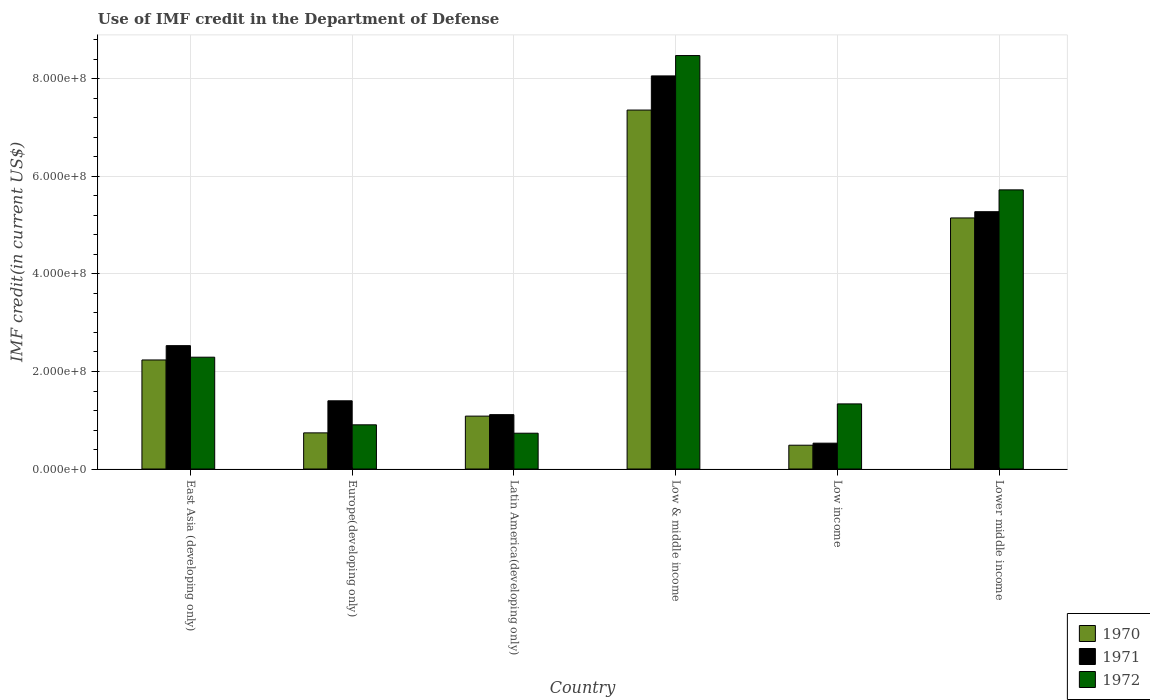How many different coloured bars are there?
Offer a terse response. 3. How many groups of bars are there?
Keep it short and to the point. 6. Are the number of bars per tick equal to the number of legend labels?
Keep it short and to the point. Yes. Are the number of bars on each tick of the X-axis equal?
Keep it short and to the point. Yes. How many bars are there on the 2nd tick from the left?
Provide a succinct answer. 3. What is the label of the 5th group of bars from the left?
Your answer should be compact. Low income. What is the IMF credit in the Department of Defense in 1970 in East Asia (developing only)?
Your response must be concise. 2.24e+08. Across all countries, what is the maximum IMF credit in the Department of Defense in 1972?
Your response must be concise. 8.48e+08. Across all countries, what is the minimum IMF credit in the Department of Defense in 1970?
Your answer should be very brief. 4.88e+07. What is the total IMF credit in the Department of Defense in 1971 in the graph?
Provide a short and direct response. 1.89e+09. What is the difference between the IMF credit in the Department of Defense in 1972 in East Asia (developing only) and that in Europe(developing only)?
Provide a short and direct response. 1.39e+08. What is the difference between the IMF credit in the Department of Defense in 1971 in Latin America(developing only) and the IMF credit in the Department of Defense in 1972 in Lower middle income?
Keep it short and to the point. -4.61e+08. What is the average IMF credit in the Department of Defense in 1970 per country?
Ensure brevity in your answer.  2.84e+08. What is the difference between the IMF credit in the Department of Defense of/in 1971 and IMF credit in the Department of Defense of/in 1972 in East Asia (developing only)?
Give a very brief answer. 2.37e+07. In how many countries, is the IMF credit in the Department of Defense in 1972 greater than 480000000 US$?
Offer a very short reply. 2. What is the ratio of the IMF credit in the Department of Defense in 1970 in Latin America(developing only) to that in Lower middle income?
Give a very brief answer. 0.21. Is the IMF credit in the Department of Defense in 1971 in East Asia (developing only) less than that in Europe(developing only)?
Offer a very short reply. No. Is the difference between the IMF credit in the Department of Defense in 1971 in Low & middle income and Lower middle income greater than the difference between the IMF credit in the Department of Defense in 1972 in Low & middle income and Lower middle income?
Your response must be concise. Yes. What is the difference between the highest and the second highest IMF credit in the Department of Defense in 1970?
Offer a very short reply. 5.13e+08. What is the difference between the highest and the lowest IMF credit in the Department of Defense in 1972?
Keep it short and to the point. 7.75e+08. In how many countries, is the IMF credit in the Department of Defense in 1972 greater than the average IMF credit in the Department of Defense in 1972 taken over all countries?
Provide a succinct answer. 2. What does the 3rd bar from the right in Europe(developing only) represents?
Offer a terse response. 1970. Is it the case that in every country, the sum of the IMF credit in the Department of Defense in 1970 and IMF credit in the Department of Defense in 1972 is greater than the IMF credit in the Department of Defense in 1971?
Offer a very short reply. Yes. How many countries are there in the graph?
Your answer should be very brief. 6. Does the graph contain grids?
Provide a succinct answer. Yes. Where does the legend appear in the graph?
Provide a succinct answer. Bottom right. How many legend labels are there?
Offer a very short reply. 3. How are the legend labels stacked?
Keep it short and to the point. Vertical. What is the title of the graph?
Provide a succinct answer. Use of IMF credit in the Department of Defense. What is the label or title of the X-axis?
Make the answer very short. Country. What is the label or title of the Y-axis?
Your response must be concise. IMF credit(in current US$). What is the IMF credit(in current US$) of 1970 in East Asia (developing only)?
Keep it short and to the point. 2.24e+08. What is the IMF credit(in current US$) in 1971 in East Asia (developing only)?
Provide a succinct answer. 2.53e+08. What is the IMF credit(in current US$) in 1972 in East Asia (developing only)?
Ensure brevity in your answer.  2.29e+08. What is the IMF credit(in current US$) of 1970 in Europe(developing only)?
Make the answer very short. 7.41e+07. What is the IMF credit(in current US$) in 1971 in Europe(developing only)?
Give a very brief answer. 1.40e+08. What is the IMF credit(in current US$) in 1972 in Europe(developing only)?
Your response must be concise. 9.07e+07. What is the IMF credit(in current US$) of 1970 in Latin America(developing only)?
Provide a short and direct response. 1.09e+08. What is the IMF credit(in current US$) of 1971 in Latin America(developing only)?
Your answer should be compact. 1.12e+08. What is the IMF credit(in current US$) of 1972 in Latin America(developing only)?
Offer a very short reply. 7.34e+07. What is the IMF credit(in current US$) of 1970 in Low & middle income?
Offer a terse response. 7.36e+08. What is the IMF credit(in current US$) in 1971 in Low & middle income?
Your response must be concise. 8.06e+08. What is the IMF credit(in current US$) of 1972 in Low & middle income?
Keep it short and to the point. 8.48e+08. What is the IMF credit(in current US$) of 1970 in Low income?
Provide a succinct answer. 4.88e+07. What is the IMF credit(in current US$) in 1971 in Low income?
Keep it short and to the point. 5.30e+07. What is the IMF credit(in current US$) in 1972 in Low income?
Offer a terse response. 1.34e+08. What is the IMF credit(in current US$) in 1970 in Lower middle income?
Your answer should be very brief. 5.15e+08. What is the IMF credit(in current US$) of 1971 in Lower middle income?
Offer a very short reply. 5.28e+08. What is the IMF credit(in current US$) of 1972 in Lower middle income?
Your answer should be compact. 5.73e+08. Across all countries, what is the maximum IMF credit(in current US$) in 1970?
Your answer should be very brief. 7.36e+08. Across all countries, what is the maximum IMF credit(in current US$) in 1971?
Keep it short and to the point. 8.06e+08. Across all countries, what is the maximum IMF credit(in current US$) of 1972?
Offer a terse response. 8.48e+08. Across all countries, what is the minimum IMF credit(in current US$) in 1970?
Provide a short and direct response. 4.88e+07. Across all countries, what is the minimum IMF credit(in current US$) of 1971?
Your answer should be compact. 5.30e+07. Across all countries, what is the minimum IMF credit(in current US$) of 1972?
Offer a terse response. 7.34e+07. What is the total IMF credit(in current US$) in 1970 in the graph?
Offer a very short reply. 1.71e+09. What is the total IMF credit(in current US$) of 1971 in the graph?
Offer a terse response. 1.89e+09. What is the total IMF credit(in current US$) in 1972 in the graph?
Ensure brevity in your answer.  1.95e+09. What is the difference between the IMF credit(in current US$) of 1970 in East Asia (developing only) and that in Europe(developing only)?
Your response must be concise. 1.50e+08. What is the difference between the IMF credit(in current US$) of 1971 in East Asia (developing only) and that in Europe(developing only)?
Your response must be concise. 1.13e+08. What is the difference between the IMF credit(in current US$) of 1972 in East Asia (developing only) and that in Europe(developing only)?
Provide a succinct answer. 1.39e+08. What is the difference between the IMF credit(in current US$) of 1970 in East Asia (developing only) and that in Latin America(developing only)?
Offer a terse response. 1.15e+08. What is the difference between the IMF credit(in current US$) of 1971 in East Asia (developing only) and that in Latin America(developing only)?
Offer a very short reply. 1.42e+08. What is the difference between the IMF credit(in current US$) of 1972 in East Asia (developing only) and that in Latin America(developing only)?
Ensure brevity in your answer.  1.56e+08. What is the difference between the IMF credit(in current US$) of 1970 in East Asia (developing only) and that in Low & middle income?
Make the answer very short. -5.13e+08. What is the difference between the IMF credit(in current US$) of 1971 in East Asia (developing only) and that in Low & middle income?
Your response must be concise. -5.53e+08. What is the difference between the IMF credit(in current US$) of 1972 in East Asia (developing only) and that in Low & middle income?
Your answer should be compact. -6.19e+08. What is the difference between the IMF credit(in current US$) in 1970 in East Asia (developing only) and that in Low income?
Offer a very short reply. 1.75e+08. What is the difference between the IMF credit(in current US$) of 1971 in East Asia (developing only) and that in Low income?
Make the answer very short. 2.00e+08. What is the difference between the IMF credit(in current US$) in 1972 in East Asia (developing only) and that in Low income?
Your response must be concise. 9.58e+07. What is the difference between the IMF credit(in current US$) of 1970 in East Asia (developing only) and that in Lower middle income?
Make the answer very short. -2.91e+08. What is the difference between the IMF credit(in current US$) in 1971 in East Asia (developing only) and that in Lower middle income?
Give a very brief answer. -2.75e+08. What is the difference between the IMF credit(in current US$) of 1972 in East Asia (developing only) and that in Lower middle income?
Offer a terse response. -3.43e+08. What is the difference between the IMF credit(in current US$) of 1970 in Europe(developing only) and that in Latin America(developing only)?
Provide a short and direct response. -3.44e+07. What is the difference between the IMF credit(in current US$) of 1971 in Europe(developing only) and that in Latin America(developing only)?
Provide a short and direct response. 2.84e+07. What is the difference between the IMF credit(in current US$) of 1972 in Europe(developing only) and that in Latin America(developing only)?
Provide a short and direct response. 1.72e+07. What is the difference between the IMF credit(in current US$) in 1970 in Europe(developing only) and that in Low & middle income?
Ensure brevity in your answer.  -6.62e+08. What is the difference between the IMF credit(in current US$) of 1971 in Europe(developing only) and that in Low & middle income?
Your response must be concise. -6.66e+08. What is the difference between the IMF credit(in current US$) of 1972 in Europe(developing only) and that in Low & middle income?
Your answer should be very brief. -7.57e+08. What is the difference between the IMF credit(in current US$) of 1970 in Europe(developing only) and that in Low income?
Offer a very short reply. 2.53e+07. What is the difference between the IMF credit(in current US$) in 1971 in Europe(developing only) and that in Low income?
Give a very brief answer. 8.69e+07. What is the difference between the IMF credit(in current US$) in 1972 in Europe(developing only) and that in Low income?
Ensure brevity in your answer.  -4.29e+07. What is the difference between the IMF credit(in current US$) in 1970 in Europe(developing only) and that in Lower middle income?
Provide a succinct answer. -4.41e+08. What is the difference between the IMF credit(in current US$) in 1971 in Europe(developing only) and that in Lower middle income?
Offer a terse response. -3.88e+08. What is the difference between the IMF credit(in current US$) in 1972 in Europe(developing only) and that in Lower middle income?
Your answer should be compact. -4.82e+08. What is the difference between the IMF credit(in current US$) of 1970 in Latin America(developing only) and that in Low & middle income?
Ensure brevity in your answer.  -6.28e+08. What is the difference between the IMF credit(in current US$) in 1971 in Latin America(developing only) and that in Low & middle income?
Your response must be concise. -6.95e+08. What is the difference between the IMF credit(in current US$) in 1972 in Latin America(developing only) and that in Low & middle income?
Keep it short and to the point. -7.75e+08. What is the difference between the IMF credit(in current US$) of 1970 in Latin America(developing only) and that in Low income?
Keep it short and to the point. 5.97e+07. What is the difference between the IMF credit(in current US$) of 1971 in Latin America(developing only) and that in Low income?
Provide a succinct answer. 5.85e+07. What is the difference between the IMF credit(in current US$) in 1972 in Latin America(developing only) and that in Low income?
Offer a terse response. -6.01e+07. What is the difference between the IMF credit(in current US$) of 1970 in Latin America(developing only) and that in Lower middle income?
Your response must be concise. -4.06e+08. What is the difference between the IMF credit(in current US$) in 1971 in Latin America(developing only) and that in Lower middle income?
Your response must be concise. -4.16e+08. What is the difference between the IMF credit(in current US$) in 1972 in Latin America(developing only) and that in Lower middle income?
Make the answer very short. -4.99e+08. What is the difference between the IMF credit(in current US$) of 1970 in Low & middle income and that in Low income?
Provide a short and direct response. 6.87e+08. What is the difference between the IMF credit(in current US$) in 1971 in Low & middle income and that in Low income?
Provide a short and direct response. 7.53e+08. What is the difference between the IMF credit(in current US$) in 1972 in Low & middle income and that in Low income?
Offer a very short reply. 7.14e+08. What is the difference between the IMF credit(in current US$) in 1970 in Low & middle income and that in Lower middle income?
Give a very brief answer. 2.21e+08. What is the difference between the IMF credit(in current US$) of 1971 in Low & middle income and that in Lower middle income?
Ensure brevity in your answer.  2.79e+08. What is the difference between the IMF credit(in current US$) in 1972 in Low & middle income and that in Lower middle income?
Your answer should be very brief. 2.76e+08. What is the difference between the IMF credit(in current US$) of 1970 in Low income and that in Lower middle income?
Give a very brief answer. -4.66e+08. What is the difference between the IMF credit(in current US$) in 1971 in Low income and that in Lower middle income?
Give a very brief answer. -4.75e+08. What is the difference between the IMF credit(in current US$) of 1972 in Low income and that in Lower middle income?
Keep it short and to the point. -4.39e+08. What is the difference between the IMF credit(in current US$) in 1970 in East Asia (developing only) and the IMF credit(in current US$) in 1971 in Europe(developing only)?
Provide a short and direct response. 8.38e+07. What is the difference between the IMF credit(in current US$) of 1970 in East Asia (developing only) and the IMF credit(in current US$) of 1972 in Europe(developing only)?
Make the answer very short. 1.33e+08. What is the difference between the IMF credit(in current US$) in 1971 in East Asia (developing only) and the IMF credit(in current US$) in 1972 in Europe(developing only)?
Make the answer very short. 1.62e+08. What is the difference between the IMF credit(in current US$) in 1970 in East Asia (developing only) and the IMF credit(in current US$) in 1971 in Latin America(developing only)?
Ensure brevity in your answer.  1.12e+08. What is the difference between the IMF credit(in current US$) of 1970 in East Asia (developing only) and the IMF credit(in current US$) of 1972 in Latin America(developing only)?
Your answer should be very brief. 1.50e+08. What is the difference between the IMF credit(in current US$) in 1971 in East Asia (developing only) and the IMF credit(in current US$) in 1972 in Latin America(developing only)?
Provide a succinct answer. 1.80e+08. What is the difference between the IMF credit(in current US$) in 1970 in East Asia (developing only) and the IMF credit(in current US$) in 1971 in Low & middle income?
Your response must be concise. -5.83e+08. What is the difference between the IMF credit(in current US$) of 1970 in East Asia (developing only) and the IMF credit(in current US$) of 1972 in Low & middle income?
Make the answer very short. -6.24e+08. What is the difference between the IMF credit(in current US$) in 1971 in East Asia (developing only) and the IMF credit(in current US$) in 1972 in Low & middle income?
Your response must be concise. -5.95e+08. What is the difference between the IMF credit(in current US$) of 1970 in East Asia (developing only) and the IMF credit(in current US$) of 1971 in Low income?
Provide a short and direct response. 1.71e+08. What is the difference between the IMF credit(in current US$) of 1970 in East Asia (developing only) and the IMF credit(in current US$) of 1972 in Low income?
Ensure brevity in your answer.  9.01e+07. What is the difference between the IMF credit(in current US$) in 1971 in East Asia (developing only) and the IMF credit(in current US$) in 1972 in Low income?
Ensure brevity in your answer.  1.19e+08. What is the difference between the IMF credit(in current US$) in 1970 in East Asia (developing only) and the IMF credit(in current US$) in 1971 in Lower middle income?
Make the answer very short. -3.04e+08. What is the difference between the IMF credit(in current US$) of 1970 in East Asia (developing only) and the IMF credit(in current US$) of 1972 in Lower middle income?
Ensure brevity in your answer.  -3.49e+08. What is the difference between the IMF credit(in current US$) of 1971 in East Asia (developing only) and the IMF credit(in current US$) of 1972 in Lower middle income?
Keep it short and to the point. -3.20e+08. What is the difference between the IMF credit(in current US$) of 1970 in Europe(developing only) and the IMF credit(in current US$) of 1971 in Latin America(developing only)?
Your answer should be very brief. -3.74e+07. What is the difference between the IMF credit(in current US$) of 1970 in Europe(developing only) and the IMF credit(in current US$) of 1972 in Latin America(developing only)?
Your response must be concise. 7.05e+05. What is the difference between the IMF credit(in current US$) of 1971 in Europe(developing only) and the IMF credit(in current US$) of 1972 in Latin America(developing only)?
Keep it short and to the point. 6.65e+07. What is the difference between the IMF credit(in current US$) in 1970 in Europe(developing only) and the IMF credit(in current US$) in 1971 in Low & middle income?
Provide a succinct answer. -7.32e+08. What is the difference between the IMF credit(in current US$) of 1970 in Europe(developing only) and the IMF credit(in current US$) of 1972 in Low & middle income?
Give a very brief answer. -7.74e+08. What is the difference between the IMF credit(in current US$) in 1971 in Europe(developing only) and the IMF credit(in current US$) in 1972 in Low & middle income?
Make the answer very short. -7.08e+08. What is the difference between the IMF credit(in current US$) in 1970 in Europe(developing only) and the IMF credit(in current US$) in 1971 in Low income?
Offer a terse response. 2.11e+07. What is the difference between the IMF credit(in current US$) of 1970 in Europe(developing only) and the IMF credit(in current US$) of 1972 in Low income?
Provide a short and direct response. -5.94e+07. What is the difference between the IMF credit(in current US$) of 1971 in Europe(developing only) and the IMF credit(in current US$) of 1972 in Low income?
Your answer should be compact. 6.35e+06. What is the difference between the IMF credit(in current US$) in 1970 in Europe(developing only) and the IMF credit(in current US$) in 1971 in Lower middle income?
Provide a short and direct response. -4.54e+08. What is the difference between the IMF credit(in current US$) in 1970 in Europe(developing only) and the IMF credit(in current US$) in 1972 in Lower middle income?
Offer a terse response. -4.98e+08. What is the difference between the IMF credit(in current US$) in 1971 in Europe(developing only) and the IMF credit(in current US$) in 1972 in Lower middle income?
Your answer should be very brief. -4.33e+08. What is the difference between the IMF credit(in current US$) in 1970 in Latin America(developing only) and the IMF credit(in current US$) in 1971 in Low & middle income?
Your answer should be very brief. -6.98e+08. What is the difference between the IMF credit(in current US$) of 1970 in Latin America(developing only) and the IMF credit(in current US$) of 1972 in Low & middle income?
Offer a very short reply. -7.40e+08. What is the difference between the IMF credit(in current US$) in 1971 in Latin America(developing only) and the IMF credit(in current US$) in 1972 in Low & middle income?
Provide a short and direct response. -7.37e+08. What is the difference between the IMF credit(in current US$) in 1970 in Latin America(developing only) and the IMF credit(in current US$) in 1971 in Low income?
Provide a succinct answer. 5.55e+07. What is the difference between the IMF credit(in current US$) of 1970 in Latin America(developing only) and the IMF credit(in current US$) of 1972 in Low income?
Offer a very short reply. -2.50e+07. What is the difference between the IMF credit(in current US$) of 1971 in Latin America(developing only) and the IMF credit(in current US$) of 1972 in Low income?
Offer a terse response. -2.20e+07. What is the difference between the IMF credit(in current US$) of 1970 in Latin America(developing only) and the IMF credit(in current US$) of 1971 in Lower middle income?
Offer a very short reply. -4.19e+08. What is the difference between the IMF credit(in current US$) in 1970 in Latin America(developing only) and the IMF credit(in current US$) in 1972 in Lower middle income?
Your response must be concise. -4.64e+08. What is the difference between the IMF credit(in current US$) of 1971 in Latin America(developing only) and the IMF credit(in current US$) of 1972 in Lower middle income?
Your answer should be very brief. -4.61e+08. What is the difference between the IMF credit(in current US$) in 1970 in Low & middle income and the IMF credit(in current US$) in 1971 in Low income?
Offer a very short reply. 6.83e+08. What is the difference between the IMF credit(in current US$) of 1970 in Low & middle income and the IMF credit(in current US$) of 1972 in Low income?
Give a very brief answer. 6.03e+08. What is the difference between the IMF credit(in current US$) in 1971 in Low & middle income and the IMF credit(in current US$) in 1972 in Low income?
Offer a very short reply. 6.73e+08. What is the difference between the IMF credit(in current US$) of 1970 in Low & middle income and the IMF credit(in current US$) of 1971 in Lower middle income?
Your response must be concise. 2.08e+08. What is the difference between the IMF credit(in current US$) in 1970 in Low & middle income and the IMF credit(in current US$) in 1972 in Lower middle income?
Give a very brief answer. 1.64e+08. What is the difference between the IMF credit(in current US$) of 1971 in Low & middle income and the IMF credit(in current US$) of 1972 in Lower middle income?
Make the answer very short. 2.34e+08. What is the difference between the IMF credit(in current US$) in 1970 in Low income and the IMF credit(in current US$) in 1971 in Lower middle income?
Provide a short and direct response. -4.79e+08. What is the difference between the IMF credit(in current US$) of 1970 in Low income and the IMF credit(in current US$) of 1972 in Lower middle income?
Make the answer very short. -5.24e+08. What is the difference between the IMF credit(in current US$) in 1971 in Low income and the IMF credit(in current US$) in 1972 in Lower middle income?
Your response must be concise. -5.20e+08. What is the average IMF credit(in current US$) in 1970 per country?
Offer a terse response. 2.84e+08. What is the average IMF credit(in current US$) in 1971 per country?
Your answer should be compact. 3.15e+08. What is the average IMF credit(in current US$) in 1972 per country?
Your answer should be very brief. 3.25e+08. What is the difference between the IMF credit(in current US$) of 1970 and IMF credit(in current US$) of 1971 in East Asia (developing only)?
Keep it short and to the point. -2.93e+07. What is the difference between the IMF credit(in current US$) of 1970 and IMF credit(in current US$) of 1972 in East Asia (developing only)?
Offer a very short reply. -5.66e+06. What is the difference between the IMF credit(in current US$) of 1971 and IMF credit(in current US$) of 1972 in East Asia (developing only)?
Provide a short and direct response. 2.37e+07. What is the difference between the IMF credit(in current US$) of 1970 and IMF credit(in current US$) of 1971 in Europe(developing only)?
Keep it short and to the point. -6.58e+07. What is the difference between the IMF credit(in current US$) in 1970 and IMF credit(in current US$) in 1972 in Europe(developing only)?
Keep it short and to the point. -1.65e+07. What is the difference between the IMF credit(in current US$) in 1971 and IMF credit(in current US$) in 1972 in Europe(developing only)?
Provide a short and direct response. 4.93e+07. What is the difference between the IMF credit(in current US$) of 1970 and IMF credit(in current US$) of 1971 in Latin America(developing only)?
Your answer should be very brief. -3.01e+06. What is the difference between the IMF credit(in current US$) in 1970 and IMF credit(in current US$) in 1972 in Latin America(developing only)?
Keep it short and to the point. 3.51e+07. What is the difference between the IMF credit(in current US$) of 1971 and IMF credit(in current US$) of 1972 in Latin America(developing only)?
Your answer should be very brief. 3.81e+07. What is the difference between the IMF credit(in current US$) in 1970 and IMF credit(in current US$) in 1971 in Low & middle income?
Offer a very short reply. -7.00e+07. What is the difference between the IMF credit(in current US$) in 1970 and IMF credit(in current US$) in 1972 in Low & middle income?
Make the answer very short. -1.12e+08. What is the difference between the IMF credit(in current US$) in 1971 and IMF credit(in current US$) in 1972 in Low & middle income?
Keep it short and to the point. -4.18e+07. What is the difference between the IMF credit(in current US$) of 1970 and IMF credit(in current US$) of 1971 in Low income?
Ensure brevity in your answer.  -4.21e+06. What is the difference between the IMF credit(in current US$) of 1970 and IMF credit(in current US$) of 1972 in Low income?
Give a very brief answer. -8.47e+07. What is the difference between the IMF credit(in current US$) in 1971 and IMF credit(in current US$) in 1972 in Low income?
Your answer should be compact. -8.05e+07. What is the difference between the IMF credit(in current US$) in 1970 and IMF credit(in current US$) in 1971 in Lower middle income?
Provide a short and direct response. -1.28e+07. What is the difference between the IMF credit(in current US$) in 1970 and IMF credit(in current US$) in 1972 in Lower middle income?
Offer a terse response. -5.76e+07. What is the difference between the IMF credit(in current US$) of 1971 and IMF credit(in current US$) of 1972 in Lower middle income?
Your answer should be very brief. -4.48e+07. What is the ratio of the IMF credit(in current US$) of 1970 in East Asia (developing only) to that in Europe(developing only)?
Your answer should be compact. 3.02. What is the ratio of the IMF credit(in current US$) in 1971 in East Asia (developing only) to that in Europe(developing only)?
Offer a terse response. 1.81. What is the ratio of the IMF credit(in current US$) in 1972 in East Asia (developing only) to that in Europe(developing only)?
Provide a succinct answer. 2.53. What is the ratio of the IMF credit(in current US$) in 1970 in East Asia (developing only) to that in Latin America(developing only)?
Your answer should be compact. 2.06. What is the ratio of the IMF credit(in current US$) of 1971 in East Asia (developing only) to that in Latin America(developing only)?
Your response must be concise. 2.27. What is the ratio of the IMF credit(in current US$) of 1972 in East Asia (developing only) to that in Latin America(developing only)?
Provide a succinct answer. 3.12. What is the ratio of the IMF credit(in current US$) in 1970 in East Asia (developing only) to that in Low & middle income?
Make the answer very short. 0.3. What is the ratio of the IMF credit(in current US$) in 1971 in East Asia (developing only) to that in Low & middle income?
Your response must be concise. 0.31. What is the ratio of the IMF credit(in current US$) in 1972 in East Asia (developing only) to that in Low & middle income?
Give a very brief answer. 0.27. What is the ratio of the IMF credit(in current US$) in 1970 in East Asia (developing only) to that in Low income?
Give a very brief answer. 4.58. What is the ratio of the IMF credit(in current US$) in 1971 in East Asia (developing only) to that in Low income?
Your answer should be compact. 4.77. What is the ratio of the IMF credit(in current US$) of 1972 in East Asia (developing only) to that in Low income?
Give a very brief answer. 1.72. What is the ratio of the IMF credit(in current US$) of 1970 in East Asia (developing only) to that in Lower middle income?
Your answer should be compact. 0.43. What is the ratio of the IMF credit(in current US$) in 1971 in East Asia (developing only) to that in Lower middle income?
Your response must be concise. 0.48. What is the ratio of the IMF credit(in current US$) in 1972 in East Asia (developing only) to that in Lower middle income?
Give a very brief answer. 0.4. What is the ratio of the IMF credit(in current US$) in 1970 in Europe(developing only) to that in Latin America(developing only)?
Provide a succinct answer. 0.68. What is the ratio of the IMF credit(in current US$) in 1971 in Europe(developing only) to that in Latin America(developing only)?
Ensure brevity in your answer.  1.25. What is the ratio of the IMF credit(in current US$) of 1972 in Europe(developing only) to that in Latin America(developing only)?
Offer a terse response. 1.23. What is the ratio of the IMF credit(in current US$) in 1970 in Europe(developing only) to that in Low & middle income?
Ensure brevity in your answer.  0.1. What is the ratio of the IMF credit(in current US$) in 1971 in Europe(developing only) to that in Low & middle income?
Your answer should be compact. 0.17. What is the ratio of the IMF credit(in current US$) in 1972 in Europe(developing only) to that in Low & middle income?
Your response must be concise. 0.11. What is the ratio of the IMF credit(in current US$) in 1970 in Europe(developing only) to that in Low income?
Keep it short and to the point. 1.52. What is the ratio of the IMF credit(in current US$) in 1971 in Europe(developing only) to that in Low income?
Offer a very short reply. 2.64. What is the ratio of the IMF credit(in current US$) in 1972 in Europe(developing only) to that in Low income?
Provide a short and direct response. 0.68. What is the ratio of the IMF credit(in current US$) in 1970 in Europe(developing only) to that in Lower middle income?
Provide a succinct answer. 0.14. What is the ratio of the IMF credit(in current US$) of 1971 in Europe(developing only) to that in Lower middle income?
Offer a terse response. 0.27. What is the ratio of the IMF credit(in current US$) in 1972 in Europe(developing only) to that in Lower middle income?
Ensure brevity in your answer.  0.16. What is the ratio of the IMF credit(in current US$) in 1970 in Latin America(developing only) to that in Low & middle income?
Provide a succinct answer. 0.15. What is the ratio of the IMF credit(in current US$) of 1971 in Latin America(developing only) to that in Low & middle income?
Keep it short and to the point. 0.14. What is the ratio of the IMF credit(in current US$) of 1972 in Latin America(developing only) to that in Low & middle income?
Give a very brief answer. 0.09. What is the ratio of the IMF credit(in current US$) of 1970 in Latin America(developing only) to that in Low income?
Ensure brevity in your answer.  2.22. What is the ratio of the IMF credit(in current US$) in 1971 in Latin America(developing only) to that in Low income?
Provide a succinct answer. 2.1. What is the ratio of the IMF credit(in current US$) of 1972 in Latin America(developing only) to that in Low income?
Your answer should be very brief. 0.55. What is the ratio of the IMF credit(in current US$) of 1970 in Latin America(developing only) to that in Lower middle income?
Your answer should be very brief. 0.21. What is the ratio of the IMF credit(in current US$) in 1971 in Latin America(developing only) to that in Lower middle income?
Keep it short and to the point. 0.21. What is the ratio of the IMF credit(in current US$) in 1972 in Latin America(developing only) to that in Lower middle income?
Your response must be concise. 0.13. What is the ratio of the IMF credit(in current US$) of 1970 in Low & middle income to that in Low income?
Keep it short and to the point. 15.08. What is the ratio of the IMF credit(in current US$) in 1971 in Low & middle income to that in Low income?
Give a very brief answer. 15.21. What is the ratio of the IMF credit(in current US$) of 1972 in Low & middle income to that in Low income?
Offer a terse response. 6.35. What is the ratio of the IMF credit(in current US$) of 1970 in Low & middle income to that in Lower middle income?
Give a very brief answer. 1.43. What is the ratio of the IMF credit(in current US$) in 1971 in Low & middle income to that in Lower middle income?
Make the answer very short. 1.53. What is the ratio of the IMF credit(in current US$) in 1972 in Low & middle income to that in Lower middle income?
Provide a short and direct response. 1.48. What is the ratio of the IMF credit(in current US$) of 1970 in Low income to that in Lower middle income?
Your response must be concise. 0.09. What is the ratio of the IMF credit(in current US$) in 1971 in Low income to that in Lower middle income?
Provide a succinct answer. 0.1. What is the ratio of the IMF credit(in current US$) of 1972 in Low income to that in Lower middle income?
Provide a short and direct response. 0.23. What is the difference between the highest and the second highest IMF credit(in current US$) in 1970?
Ensure brevity in your answer.  2.21e+08. What is the difference between the highest and the second highest IMF credit(in current US$) in 1971?
Provide a succinct answer. 2.79e+08. What is the difference between the highest and the second highest IMF credit(in current US$) in 1972?
Offer a very short reply. 2.76e+08. What is the difference between the highest and the lowest IMF credit(in current US$) of 1970?
Your answer should be compact. 6.87e+08. What is the difference between the highest and the lowest IMF credit(in current US$) in 1971?
Your response must be concise. 7.53e+08. What is the difference between the highest and the lowest IMF credit(in current US$) in 1972?
Give a very brief answer. 7.75e+08. 